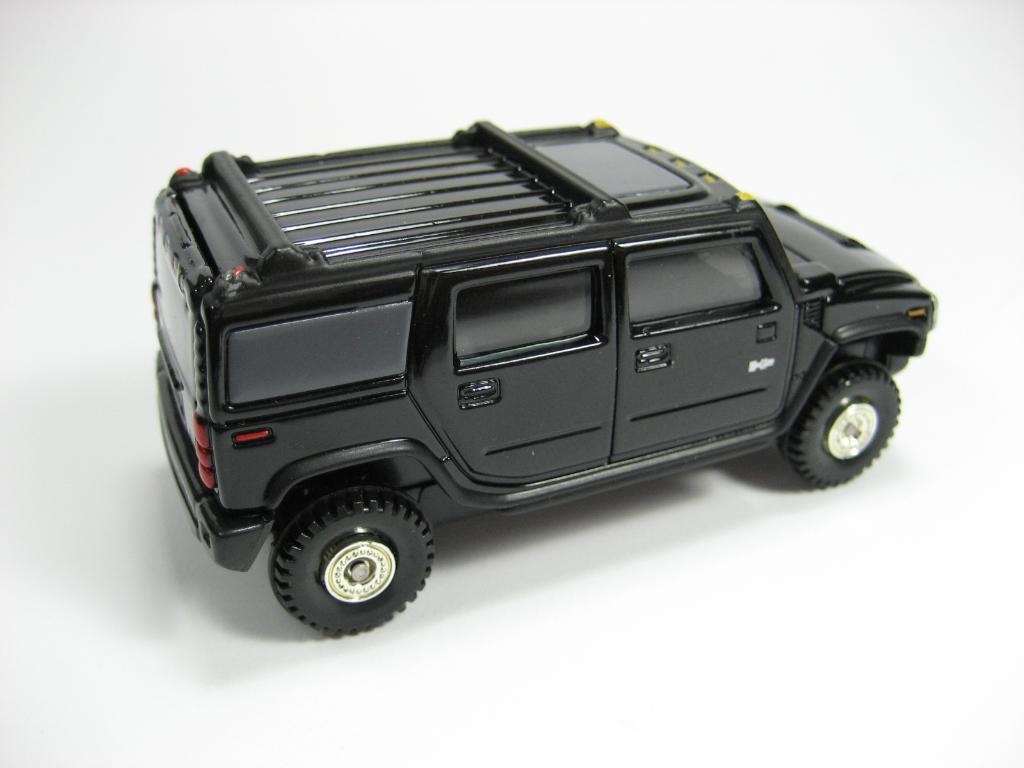What type of vehicle is in the picture? There is a black color jeep in the picture. What can be observed about the background of the image? The background of the image is white. Is there a volcano erupting in the background of the image? No, there is no volcano present in the image. What type of jewel can be seen on the hood of the jeep? There is no jewel visible on the jeep in the image. 